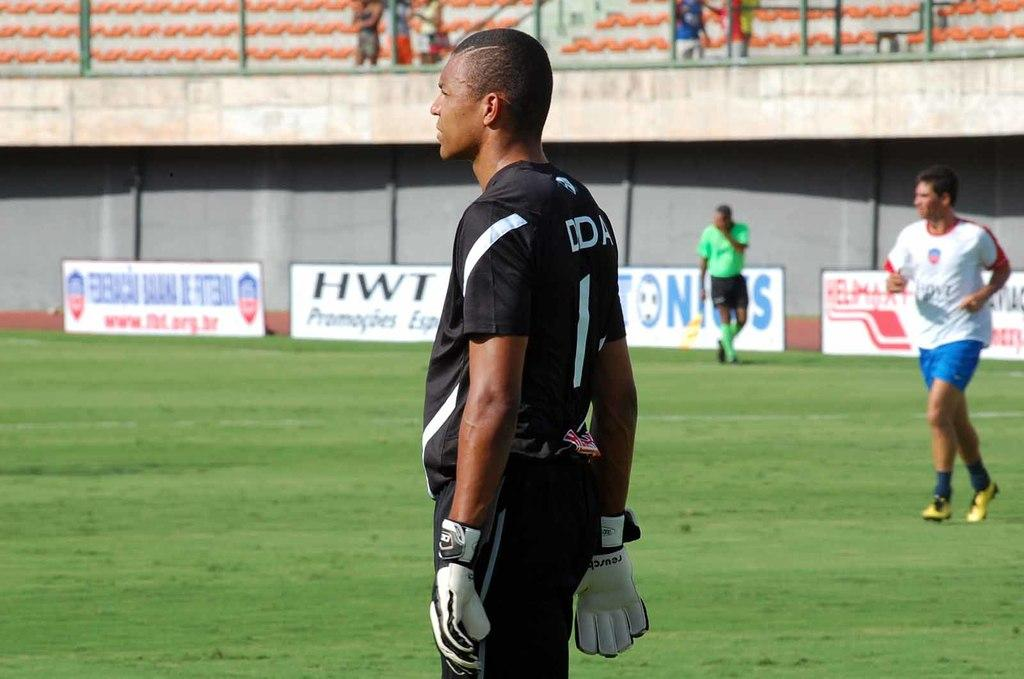<image>
Create a compact narrative representing the image presented. HWT is one of the companies advertising on the sidelines. 